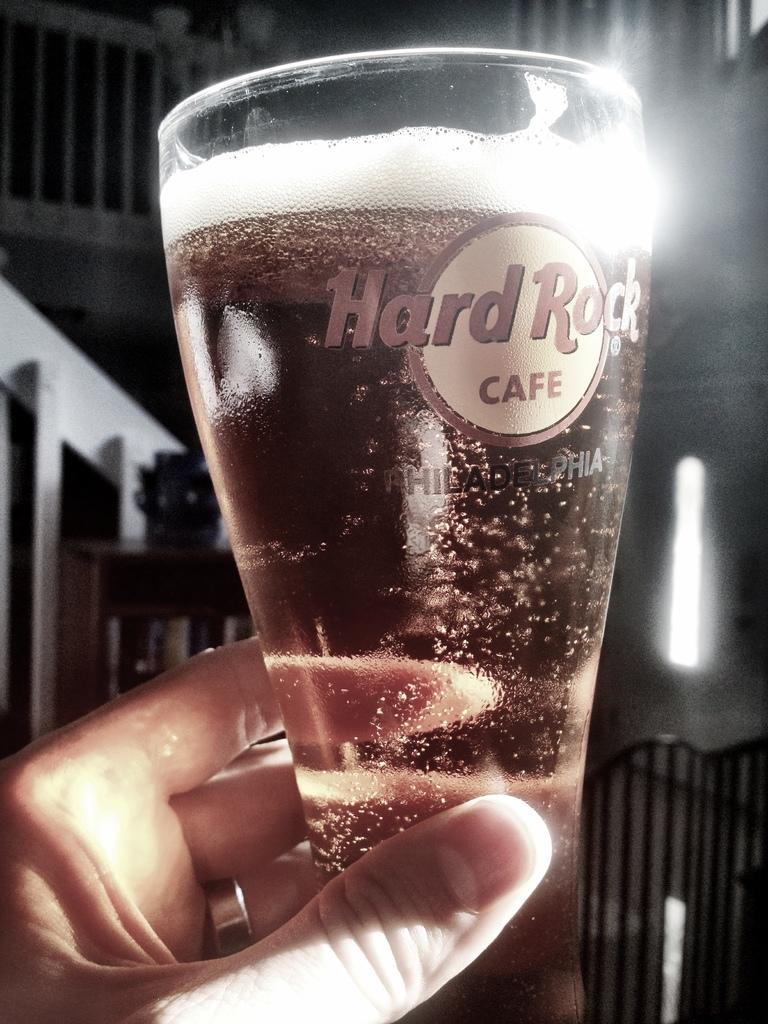<image>
Write a terse but informative summary of the picture. A hand with nice fingernails holds a glass of something from the hard rock cafe. 